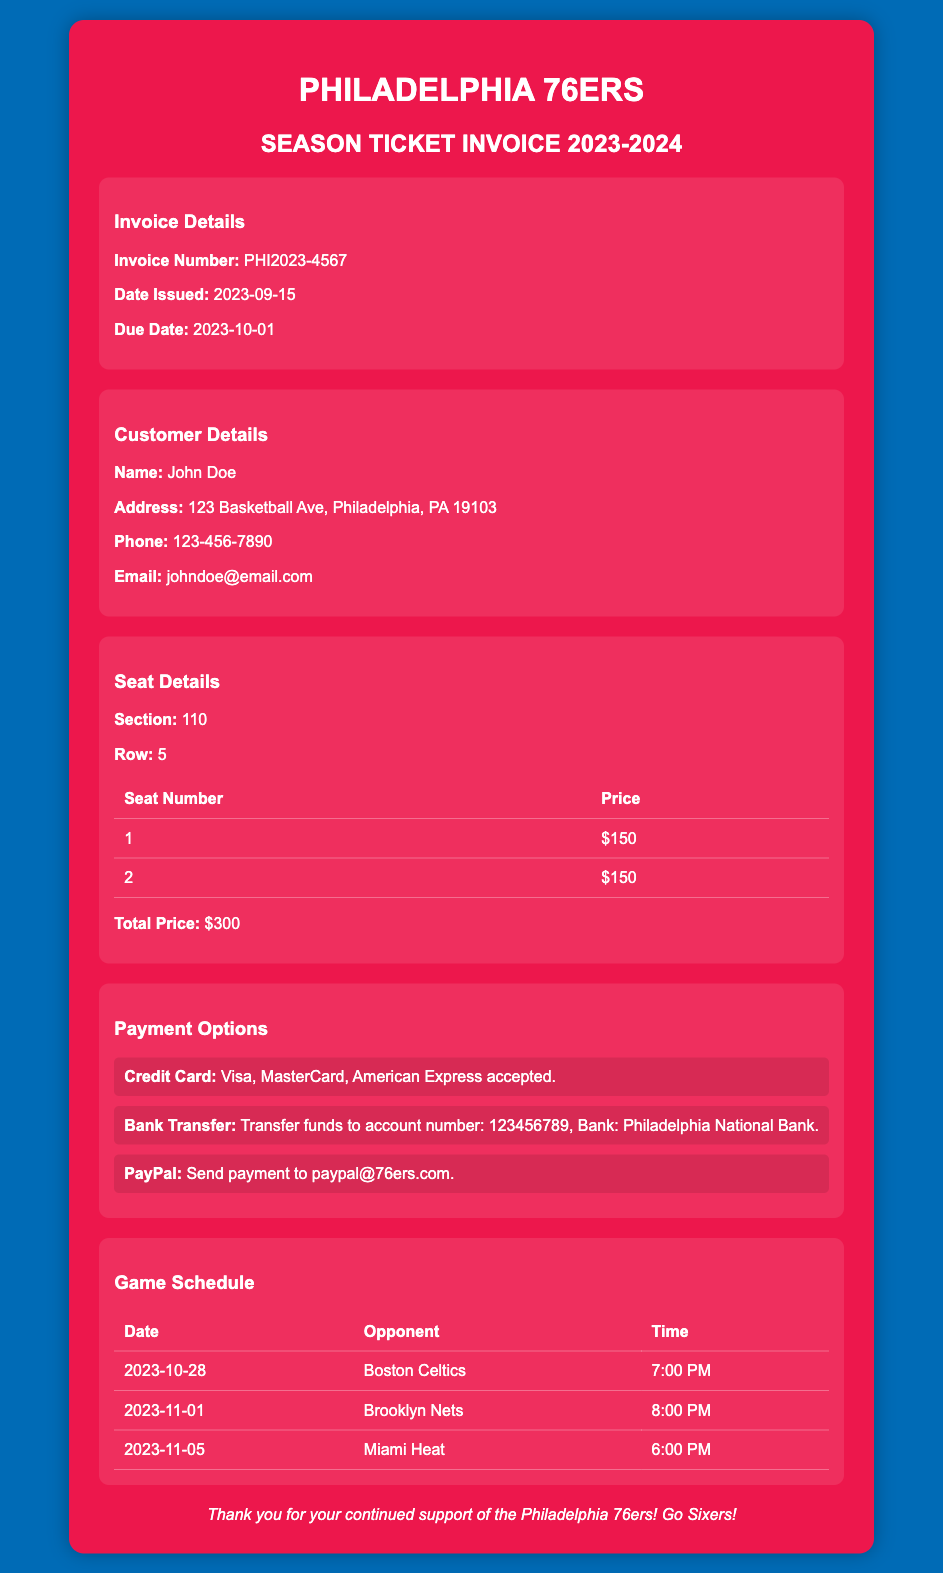What is the invoice number? The invoice number is specifically mentioned in the document as a unique identifier for the transaction.
Answer: PHI2023-4567 What is the due date? The due date indicates when the payment must be made and is clearly provided in the invoice details.
Answer: 2023-10-01 What is the total price for the tickets? The total price summarizes the cost of the tickets purchased and is stated in the seat details section.
Answer: $300 What payment options are available? The document lists several payment methods that can be used to settle the invoice.
Answer: Credit Card, Bank Transfer, PayPal Who is the customer? The customer details section specifies the name of the individual associated with the invoice.
Answer: John Doe What section is the seat located in? The seat details provide information about the specific section of the arena where the tickets are located.
Answer: 110 How many games are listed in the game schedule? The game schedule section contains a table with multiple entries for games; counting them gives the total.
Answer: 3 What is the first game date? The first game date listed in the schedule indicates when the season will start for the Philadelphia 76ers.
Answer: 2023-10-28 Which opponent do the 76ers play on November 1st? The game schedule specifies the opponent for each date, allowing for identification of specific matchups.
Answer: Brooklyn Nets 